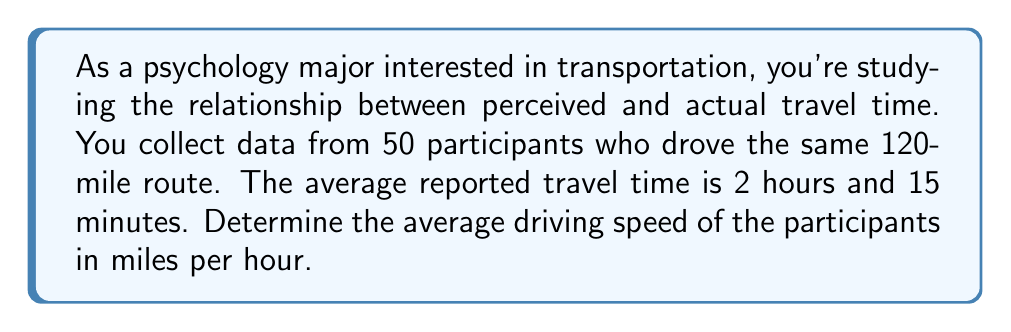Give your solution to this math problem. To solve this problem, we'll use the relationship between speed, distance, and time. The formula is:

$$\text{Speed} = \frac{\text{Distance}}{\text{Time}}$$

Let's break down the solution step-by-step:

1. Convert the time to hours:
   2 hours and 15 minutes = 2.25 hours

2. We know the distance is 120 miles, so we can plug these values into our formula:

   $$\text{Speed} = \frac{120 \text{ miles}}{2.25 \text{ hours}}$$

3. Perform the division:

   $$\text{Speed} = 53.33 \text{ miles per hour}$$

4. Round to the nearest whole number:

   $$\text{Speed} \approx 53 \text{ mph}$$

This result shows that the average driving speed of the participants was approximately 53 miles per hour. This information could be useful in analyzing how accurately people perceive their travel time and how it relates to actual speed, which is relevant to both psychology and transportation studies.
Answer: 53 mph 